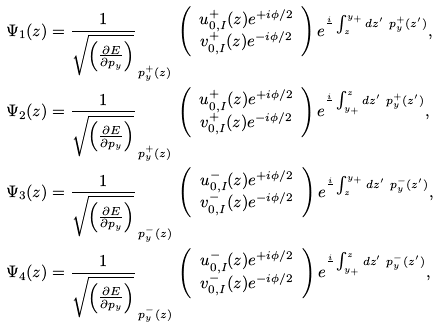Convert formula to latex. <formula><loc_0><loc_0><loc_500><loc_500>\Psi _ { 1 } ( z ) & = \frac { 1 } { \sqrt { \left ( \frac { \partial E } { \partial p _ { y } } \right ) } } _ { \, p _ { y } ^ { + } ( z ) } \, \left ( \begin{array} { c } u ^ { + } _ { 0 , I } ( z ) e ^ { + i \phi / 2 } \\ v ^ { + } _ { 0 , I } ( z ) e ^ { - i \phi / 2 } \end{array} \right ) e ^ { \frac { i } { } \int _ { z } ^ { y _ { + } } d z ^ { \prime } \ p _ { y } ^ { + } ( z ^ { \prime } ) } , \\ \Psi _ { 2 } ( z ) & = \frac { 1 } { \sqrt { \left ( \frac { \partial E } { \partial p _ { y } } \right ) } } _ { \, p _ { y } ^ { + } ( z ) } \, \left ( \begin{array} { c } u ^ { + } _ { 0 , I } ( z ) e ^ { + i \phi / 2 } \\ v ^ { + } _ { 0 , I } ( z ) e ^ { - i \phi / 2 } \end{array} \right ) e ^ { \frac { i } { } \int _ { y _ { + } } ^ { z \ } d z ^ { \prime } \ p _ { y } ^ { + } ( z ^ { \prime } ) } , \\ \Psi _ { 3 } ( z ) & = \frac { 1 } { \sqrt { \left ( \frac { \partial E } { \partial p _ { y } } \right ) } } _ { \, p _ { y } ^ { - } ( z ) } \, \left ( \begin{array} { c } u ^ { - } _ { 0 , I } ( z ) e ^ { + i \phi / 2 } \\ v ^ { - } _ { 0 , I } ( z ) e ^ { - i \phi / 2 } \end{array} \right ) e ^ { \frac { i } { } \int _ { z } ^ { y _ { + } } d z ^ { \prime } \ p _ { y } ^ { - } ( z ^ { \prime } ) } , \\ \Psi _ { 4 } ( z ) & = \frac { 1 } { \sqrt { \left ( \frac { \partial E } { \partial p _ { y } } \right ) } } _ { \, p _ { y } ^ { - } ( z ) } \, \left ( \begin{array} { c } u ^ { - } _ { 0 , I } ( z ) e ^ { + i \phi / 2 } \\ v ^ { - } _ { 0 , I } ( z ) e ^ { - i \phi / 2 } \end{array} \right ) e ^ { \frac { i } { } \int _ { y _ { + } } ^ { z \ } d z ^ { \prime } \ p _ { y } ^ { - } ( z ^ { \prime } ) } ,</formula> 